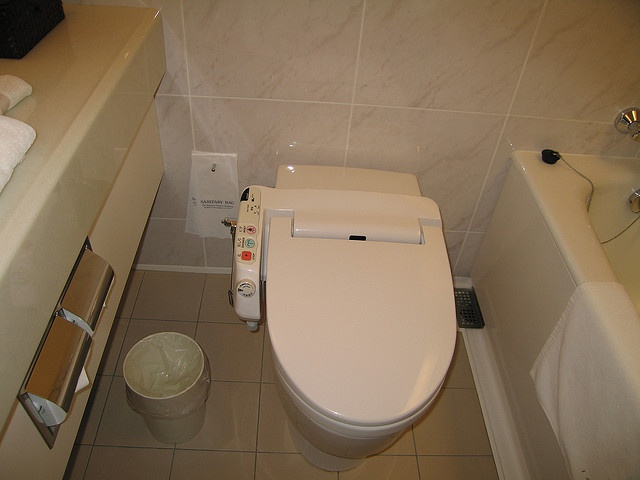Describe the objects in this image and their specific colors. I can see a toilet in black, tan, and maroon tones in this image. 